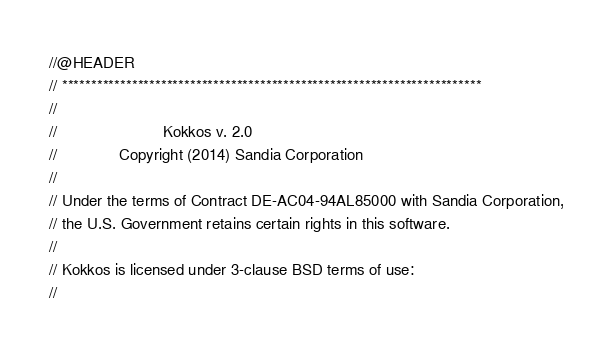<code> <loc_0><loc_0><loc_500><loc_500><_C++_>//@HEADER
// ************************************************************************
//
//                        Kokkos v. 2.0
//              Copyright (2014) Sandia Corporation
//
// Under the terms of Contract DE-AC04-94AL85000 with Sandia Corporation,
// the U.S. Government retains certain rights in this software.
//
// Kokkos is licensed under 3-clause BSD terms of use:
//</code> 